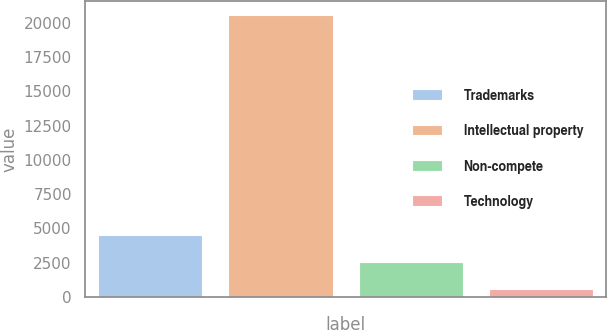Convert chart to OTSL. <chart><loc_0><loc_0><loc_500><loc_500><bar_chart><fcel>Trademarks<fcel>Intellectual property<fcel>Non-compete<fcel>Technology<nl><fcel>4545.8<fcel>20557<fcel>2544.4<fcel>543<nl></chart> 